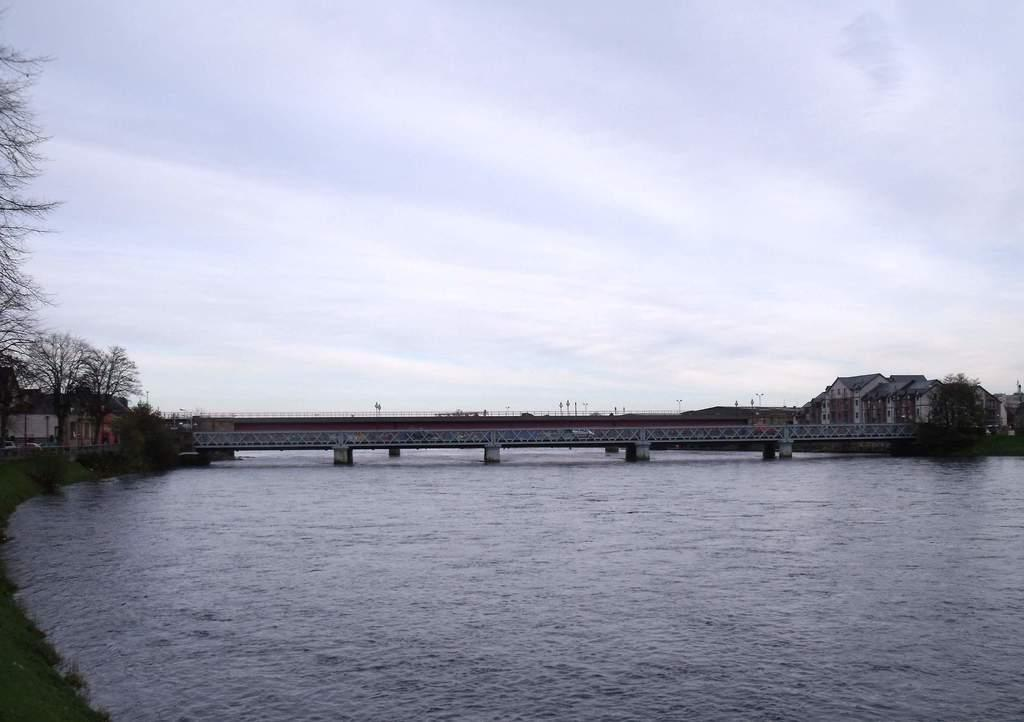What type of natural feature is present in the image? There is a river in the image. What can be seen on the left side of the image? There are trees and houses on the left side of the image. What is visible in the background of the image? There is a bridge, houses, and the sky visible in the background of the image. What type of trains can be seen crossing the bridge in the image? There are no trains present in the image; it only features a river, trees, houses, a bridge, and the sky. 